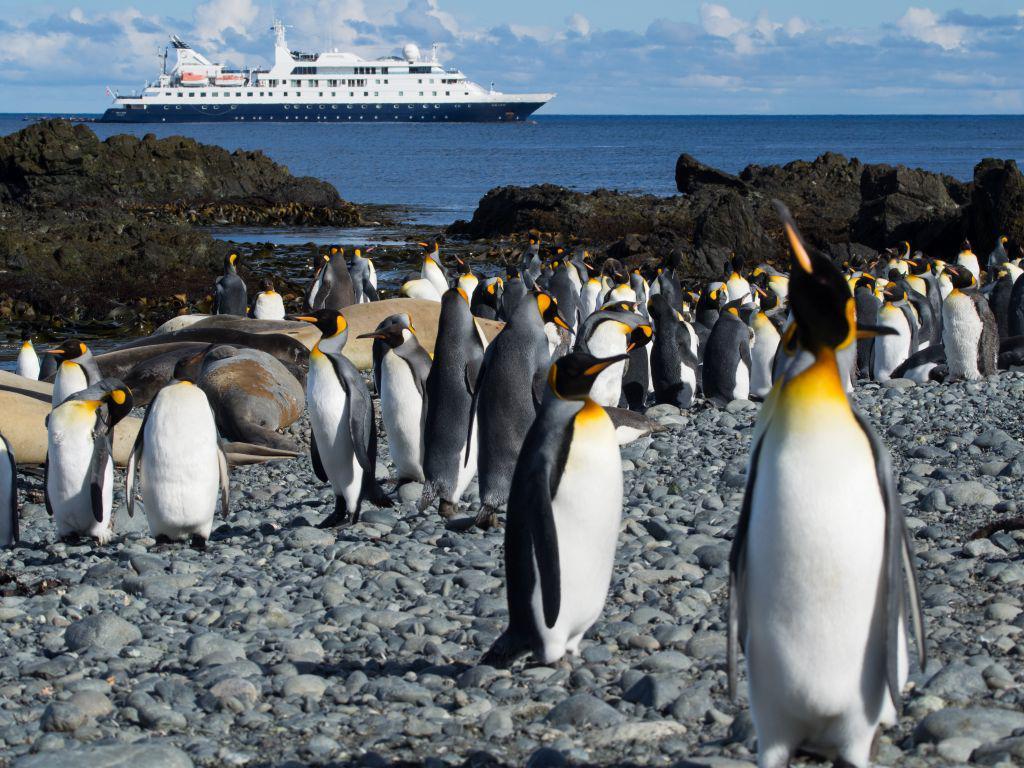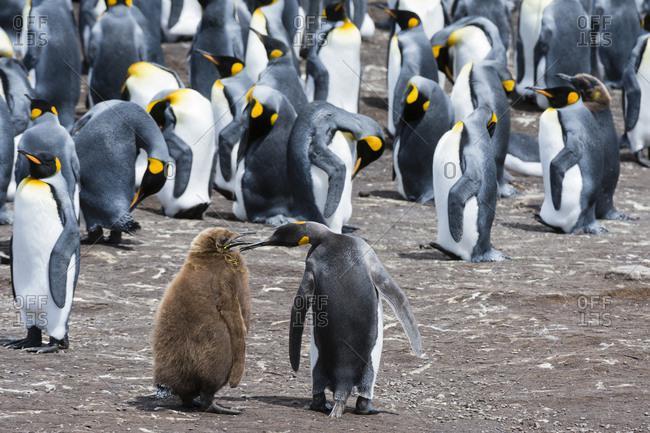The first image is the image on the left, the second image is the image on the right. Evaluate the accuracy of this statement regarding the images: "Penguins are the only living creatures in the images.". Is it true? Answer yes or no. Yes. The first image is the image on the left, the second image is the image on the right. For the images displayed, is the sentence "One of the images shows at least one brown fluffy penguin near the black and white penguins." factually correct? Answer yes or no. Yes. 